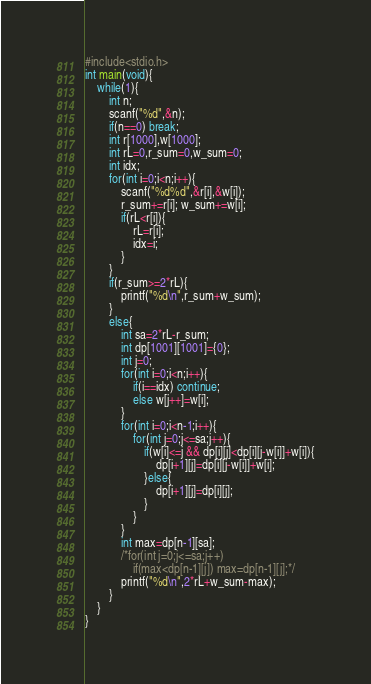<code> <loc_0><loc_0><loc_500><loc_500><_C_>#include<stdio.h>
int main(void){
    while(1){
        int n;
        scanf("%d",&n);
        if(n==0) break;
        int r[1000],w[1000];
        int rL=0,r_sum=0,w_sum=0;
        int idx;
        for(int i=0;i<n;i++){
            scanf("%d%d",&r[i],&w[i]);
            r_sum+=r[i]; w_sum+=w[i];
            if(rL<r[i]){
                rL=r[i];
                idx=i;
            }
        }
        if(r_sum>=2*rL){
            printf("%d\n",r_sum+w_sum);
        }
        else{
            int sa=2*rL-r_sum;
            int dp[1001][1001]={0};
            int j=0;
            for(int i=0;i<n;i++){
                if(i==idx) continue;
                else w[j++]=w[i];
            }
            for(int i=0;i<n-1;i++){
                for(int j=0;j<=sa;j++){
                    if(w[i]<=j && dp[i][j]<dp[i][j-w[i]]+w[i]){
                        dp[i+1][j]=dp[i][j-w[i]]+w[i];
                    }else{
                        dp[i+1][j]=dp[i][j];
                    }
                }
            }
            int max=dp[n-1][sa];
            /*for(int j=0;j<=sa;j++)
                if(max<dp[n-1][j]) max=dp[n-1][j];*/
            printf("%d\n",2*rL+w_sum-max);
        }
    }
}

</code> 